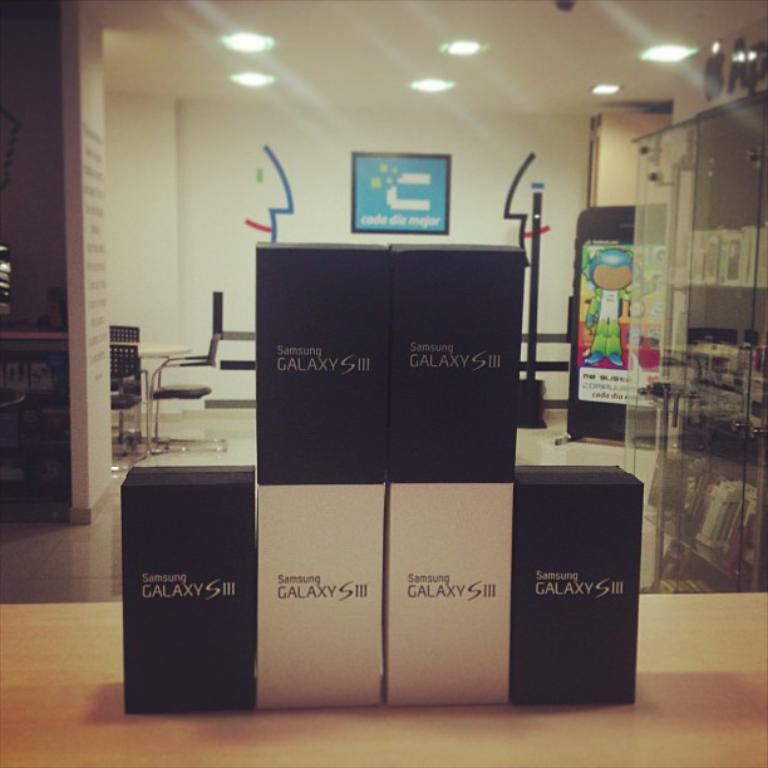Provide a one-sentence caption for the provided image. A stack of Samsung Galaxy S III phones on display at a mobile store. 